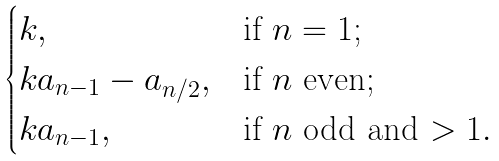Convert formula to latex. <formula><loc_0><loc_0><loc_500><loc_500>\begin{cases} k , & \text {if $n = 1$;} \\ k a _ { n - 1 } - a _ { n / 2 } , & \text {if $n$ even} ; \\ k a _ { n - 1 } , & \text {if $n$ odd and $> 1$} . \end{cases}</formula> 